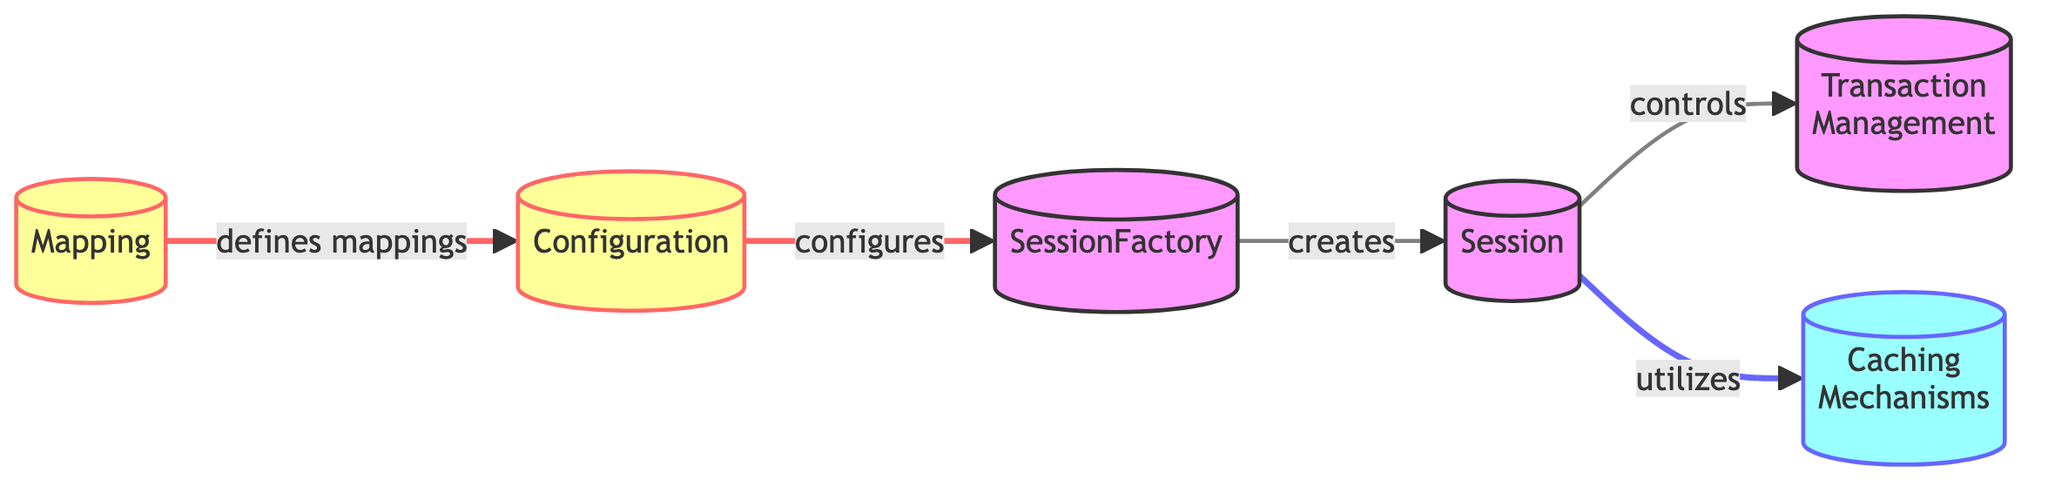What is the purpose of the SessionFactory node? The SessionFactory node is labeled as the factory for Session objects, which indicates its main role in creating Session instances that interact with the database.
Answer: Factory for Session objects How many nodes are present in the diagram? By counting each unique component listed, we find a total of six nodes: SessionFactory, Session, Transaction Management, Caching Mechanisms, Configuration, and Mapping.
Answer: Six What relationship type exists between Configuration and SessionFactory? The edge connecting Configuration to SessionFactory is labeled as "configures," indicating that the Configuration node provides the necessary settings and parameters for the SessionFactory.
Answer: configures Which component does the Session utilize? According to the diagram, the Session node is connected to the Caching Mechanisms node, labeled "utilizes," which specifies that the Session makes use of caching strategies.
Answer: Caching Mechanisms What is the primary function of the Transaction Management component? The Transaction Management node is related to the Session node by the edge labeled "controls," indicating that it manages the database transactions initiated through the Session.
Answer: Management of database transactions How does Mapping relate to Configuration? The Mapping node defines the mappings between Java classes and database tables, and it is connected to Configuration with the edge labeled "defines mappings." Therefore, Mapping influences the Configuration settings.
Answer: defines mappings Which two components does the Session node control? The Session node has control relationships with two components: it controls the Transaction Management for handling transactions and utilizes Caching Mechanisms for improved performance.
Answer: Transaction Management and Caching Mechanisms What component is created by the SessionFactory? The diagram illustrates that the SessionFactory creates the Session, indicated by the edge labeled "creates," denoting a direct relationship between the two components.
Answer: Session 